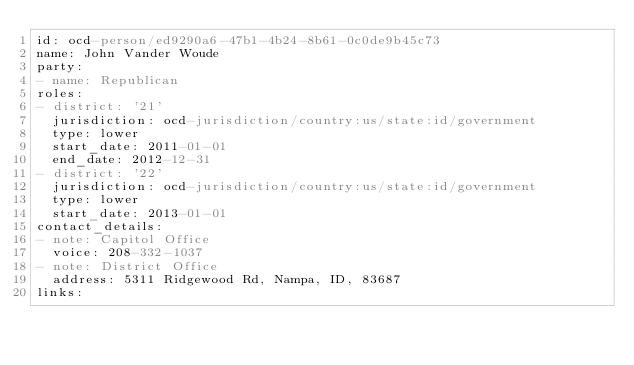Convert code to text. <code><loc_0><loc_0><loc_500><loc_500><_YAML_>id: ocd-person/ed9290a6-47b1-4b24-8b61-0c0de9b45c73
name: John Vander Woude
party:
- name: Republican
roles:
- district: '21'
  jurisdiction: ocd-jurisdiction/country:us/state:id/government
  type: lower
  start_date: 2011-01-01
  end_date: 2012-12-31
- district: '22'
  jurisdiction: ocd-jurisdiction/country:us/state:id/government
  type: lower
  start_date: 2013-01-01
contact_details:
- note: Capitol Office
  voice: 208-332-1037
- note: District Office
  address: 5311 Ridgewood Rd, Nampa, ID, 83687
links:</code> 